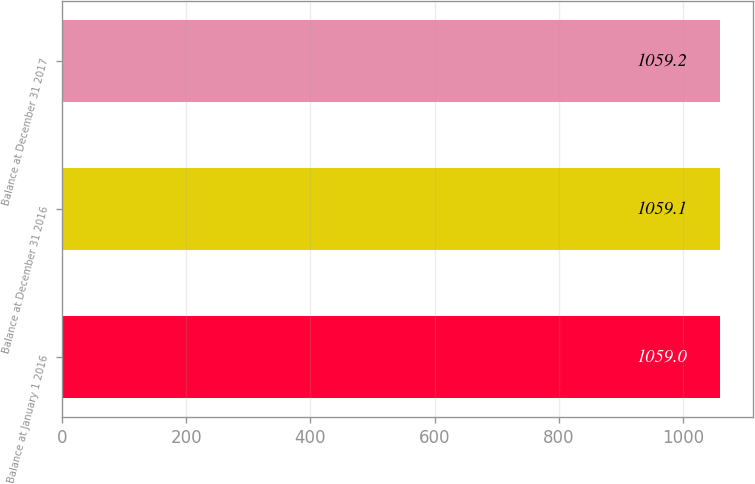Convert chart. <chart><loc_0><loc_0><loc_500><loc_500><bar_chart><fcel>Balance at January 1 2016<fcel>Balance at December 31 2016<fcel>Balance at December 31 2017<nl><fcel>1059<fcel>1059.1<fcel>1059.2<nl></chart> 